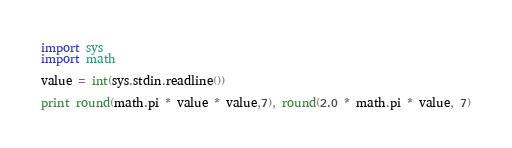Convert code to text. <code><loc_0><loc_0><loc_500><loc_500><_Python_>import sys
import math

value = int(sys.stdin.readline())

print round(math.pi * value * value,7), round(2.0 * math.pi * value, 7)</code> 